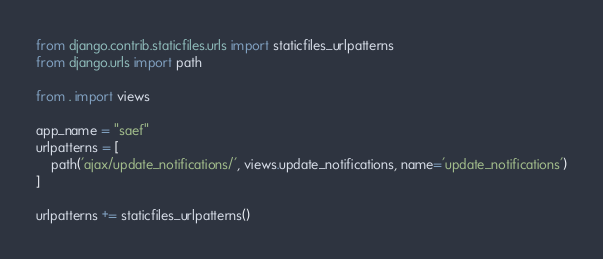Convert code to text. <code><loc_0><loc_0><loc_500><loc_500><_Python_>from django.contrib.staticfiles.urls import staticfiles_urlpatterns
from django.urls import path

from . import views

app_name = "saef"
urlpatterns = [
    path('ajax/update_notifications/', views.update_notifications, name='update_notifications')
]

urlpatterns += staticfiles_urlpatterns()
</code> 